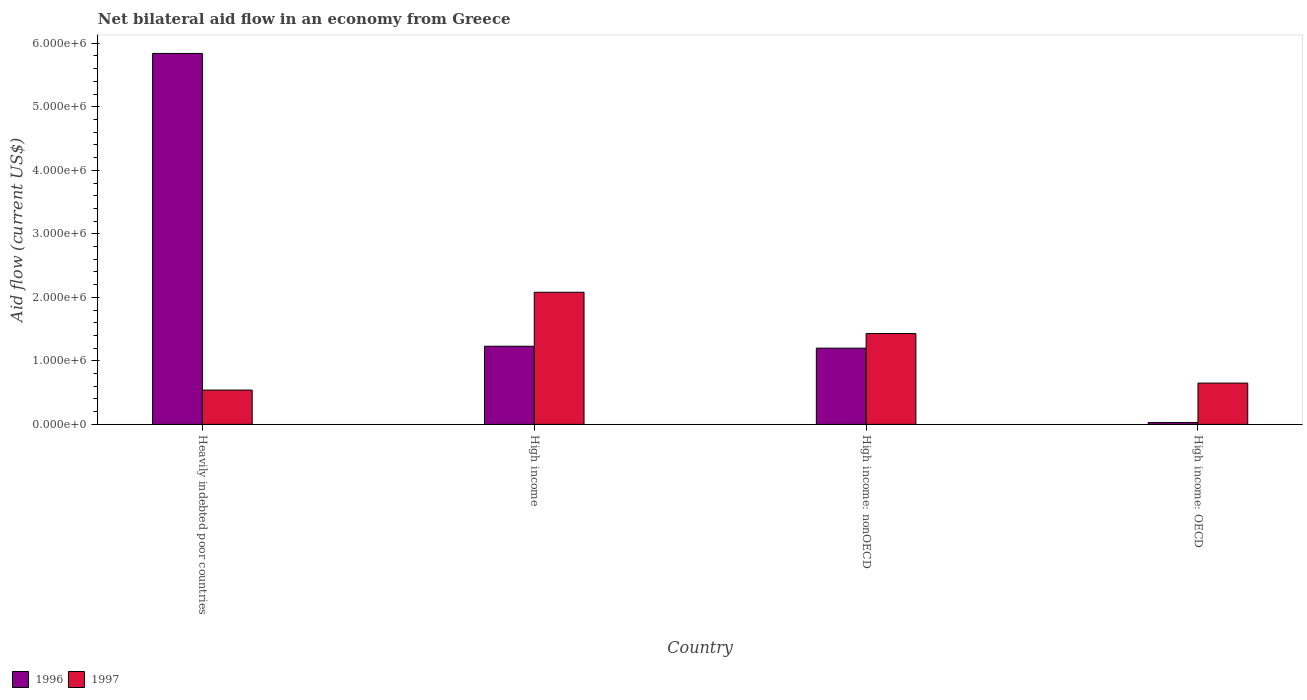How many different coloured bars are there?
Keep it short and to the point. 2. How many groups of bars are there?
Your answer should be very brief. 4. Are the number of bars on each tick of the X-axis equal?
Your answer should be compact. Yes. How many bars are there on the 1st tick from the right?
Offer a very short reply. 2. What is the label of the 1st group of bars from the left?
Provide a short and direct response. Heavily indebted poor countries. What is the net bilateral aid flow in 1997 in High income?
Ensure brevity in your answer.  2.08e+06. Across all countries, what is the maximum net bilateral aid flow in 1996?
Provide a succinct answer. 5.84e+06. In which country was the net bilateral aid flow in 1997 maximum?
Give a very brief answer. High income. In which country was the net bilateral aid flow in 1996 minimum?
Ensure brevity in your answer.  High income: OECD. What is the total net bilateral aid flow in 1996 in the graph?
Give a very brief answer. 8.30e+06. What is the difference between the net bilateral aid flow in 1996 in High income and that in High income: OECD?
Provide a succinct answer. 1.20e+06. What is the difference between the net bilateral aid flow in 1996 in Heavily indebted poor countries and the net bilateral aid flow in 1997 in High income: nonOECD?
Provide a succinct answer. 4.41e+06. What is the average net bilateral aid flow in 1997 per country?
Your response must be concise. 1.18e+06. What is the difference between the net bilateral aid flow of/in 1996 and net bilateral aid flow of/in 1997 in Heavily indebted poor countries?
Your answer should be compact. 5.30e+06. In how many countries, is the net bilateral aid flow in 1997 greater than 2800000 US$?
Make the answer very short. 0. Is the net bilateral aid flow in 1996 in Heavily indebted poor countries less than that in High income?
Keep it short and to the point. No. What is the difference between the highest and the second highest net bilateral aid flow in 1996?
Provide a succinct answer. 4.64e+06. What is the difference between the highest and the lowest net bilateral aid flow in 1996?
Give a very brief answer. 5.81e+06. What does the 1st bar from the left in Heavily indebted poor countries represents?
Provide a succinct answer. 1996. What does the 2nd bar from the right in Heavily indebted poor countries represents?
Provide a succinct answer. 1996. Are all the bars in the graph horizontal?
Your answer should be compact. No. How many countries are there in the graph?
Provide a short and direct response. 4. Are the values on the major ticks of Y-axis written in scientific E-notation?
Provide a succinct answer. Yes. Does the graph contain any zero values?
Your answer should be compact. No. Does the graph contain grids?
Your response must be concise. No. Where does the legend appear in the graph?
Offer a very short reply. Bottom left. How many legend labels are there?
Provide a succinct answer. 2. How are the legend labels stacked?
Keep it short and to the point. Horizontal. What is the title of the graph?
Offer a very short reply. Net bilateral aid flow in an economy from Greece. What is the label or title of the Y-axis?
Your response must be concise. Aid flow (current US$). What is the Aid flow (current US$) in 1996 in Heavily indebted poor countries?
Your answer should be compact. 5.84e+06. What is the Aid flow (current US$) of 1997 in Heavily indebted poor countries?
Offer a very short reply. 5.40e+05. What is the Aid flow (current US$) in 1996 in High income?
Provide a short and direct response. 1.23e+06. What is the Aid flow (current US$) in 1997 in High income?
Keep it short and to the point. 2.08e+06. What is the Aid flow (current US$) of 1996 in High income: nonOECD?
Offer a terse response. 1.20e+06. What is the Aid flow (current US$) in 1997 in High income: nonOECD?
Give a very brief answer. 1.43e+06. What is the Aid flow (current US$) in 1997 in High income: OECD?
Your answer should be very brief. 6.50e+05. Across all countries, what is the maximum Aid flow (current US$) in 1996?
Your response must be concise. 5.84e+06. Across all countries, what is the maximum Aid flow (current US$) of 1997?
Provide a succinct answer. 2.08e+06. Across all countries, what is the minimum Aid flow (current US$) of 1997?
Provide a short and direct response. 5.40e+05. What is the total Aid flow (current US$) of 1996 in the graph?
Ensure brevity in your answer.  8.30e+06. What is the total Aid flow (current US$) of 1997 in the graph?
Provide a succinct answer. 4.70e+06. What is the difference between the Aid flow (current US$) of 1996 in Heavily indebted poor countries and that in High income?
Your answer should be compact. 4.61e+06. What is the difference between the Aid flow (current US$) of 1997 in Heavily indebted poor countries and that in High income?
Ensure brevity in your answer.  -1.54e+06. What is the difference between the Aid flow (current US$) in 1996 in Heavily indebted poor countries and that in High income: nonOECD?
Provide a succinct answer. 4.64e+06. What is the difference between the Aid flow (current US$) of 1997 in Heavily indebted poor countries and that in High income: nonOECD?
Your answer should be compact. -8.90e+05. What is the difference between the Aid flow (current US$) of 1996 in Heavily indebted poor countries and that in High income: OECD?
Make the answer very short. 5.81e+06. What is the difference between the Aid flow (current US$) of 1997 in Heavily indebted poor countries and that in High income: OECD?
Your answer should be compact. -1.10e+05. What is the difference between the Aid flow (current US$) in 1997 in High income and that in High income: nonOECD?
Your answer should be very brief. 6.50e+05. What is the difference between the Aid flow (current US$) in 1996 in High income and that in High income: OECD?
Provide a short and direct response. 1.20e+06. What is the difference between the Aid flow (current US$) of 1997 in High income and that in High income: OECD?
Keep it short and to the point. 1.43e+06. What is the difference between the Aid flow (current US$) of 1996 in High income: nonOECD and that in High income: OECD?
Offer a terse response. 1.17e+06. What is the difference between the Aid flow (current US$) of 1997 in High income: nonOECD and that in High income: OECD?
Give a very brief answer. 7.80e+05. What is the difference between the Aid flow (current US$) in 1996 in Heavily indebted poor countries and the Aid flow (current US$) in 1997 in High income?
Your answer should be compact. 3.76e+06. What is the difference between the Aid flow (current US$) in 1996 in Heavily indebted poor countries and the Aid flow (current US$) in 1997 in High income: nonOECD?
Keep it short and to the point. 4.41e+06. What is the difference between the Aid flow (current US$) in 1996 in Heavily indebted poor countries and the Aid flow (current US$) in 1997 in High income: OECD?
Keep it short and to the point. 5.19e+06. What is the difference between the Aid flow (current US$) in 1996 in High income and the Aid flow (current US$) in 1997 in High income: nonOECD?
Your answer should be compact. -2.00e+05. What is the difference between the Aid flow (current US$) of 1996 in High income and the Aid flow (current US$) of 1997 in High income: OECD?
Offer a terse response. 5.80e+05. What is the difference between the Aid flow (current US$) in 1996 in High income: nonOECD and the Aid flow (current US$) in 1997 in High income: OECD?
Ensure brevity in your answer.  5.50e+05. What is the average Aid flow (current US$) of 1996 per country?
Provide a succinct answer. 2.08e+06. What is the average Aid flow (current US$) of 1997 per country?
Provide a short and direct response. 1.18e+06. What is the difference between the Aid flow (current US$) of 1996 and Aid flow (current US$) of 1997 in Heavily indebted poor countries?
Give a very brief answer. 5.30e+06. What is the difference between the Aid flow (current US$) of 1996 and Aid flow (current US$) of 1997 in High income?
Offer a very short reply. -8.50e+05. What is the difference between the Aid flow (current US$) of 1996 and Aid flow (current US$) of 1997 in High income: nonOECD?
Keep it short and to the point. -2.30e+05. What is the difference between the Aid flow (current US$) of 1996 and Aid flow (current US$) of 1997 in High income: OECD?
Your answer should be compact. -6.20e+05. What is the ratio of the Aid flow (current US$) of 1996 in Heavily indebted poor countries to that in High income?
Your answer should be compact. 4.75. What is the ratio of the Aid flow (current US$) in 1997 in Heavily indebted poor countries to that in High income?
Provide a succinct answer. 0.26. What is the ratio of the Aid flow (current US$) in 1996 in Heavily indebted poor countries to that in High income: nonOECD?
Offer a very short reply. 4.87. What is the ratio of the Aid flow (current US$) in 1997 in Heavily indebted poor countries to that in High income: nonOECD?
Offer a terse response. 0.38. What is the ratio of the Aid flow (current US$) in 1996 in Heavily indebted poor countries to that in High income: OECD?
Ensure brevity in your answer.  194.67. What is the ratio of the Aid flow (current US$) of 1997 in Heavily indebted poor countries to that in High income: OECD?
Provide a short and direct response. 0.83. What is the ratio of the Aid flow (current US$) in 1996 in High income to that in High income: nonOECD?
Make the answer very short. 1.02. What is the ratio of the Aid flow (current US$) in 1997 in High income to that in High income: nonOECD?
Ensure brevity in your answer.  1.45. What is the ratio of the Aid flow (current US$) in 1996 in High income: nonOECD to that in High income: OECD?
Provide a succinct answer. 40. What is the ratio of the Aid flow (current US$) of 1997 in High income: nonOECD to that in High income: OECD?
Your answer should be compact. 2.2. What is the difference between the highest and the second highest Aid flow (current US$) in 1996?
Your answer should be very brief. 4.61e+06. What is the difference between the highest and the second highest Aid flow (current US$) of 1997?
Ensure brevity in your answer.  6.50e+05. What is the difference between the highest and the lowest Aid flow (current US$) in 1996?
Provide a short and direct response. 5.81e+06. What is the difference between the highest and the lowest Aid flow (current US$) in 1997?
Give a very brief answer. 1.54e+06. 